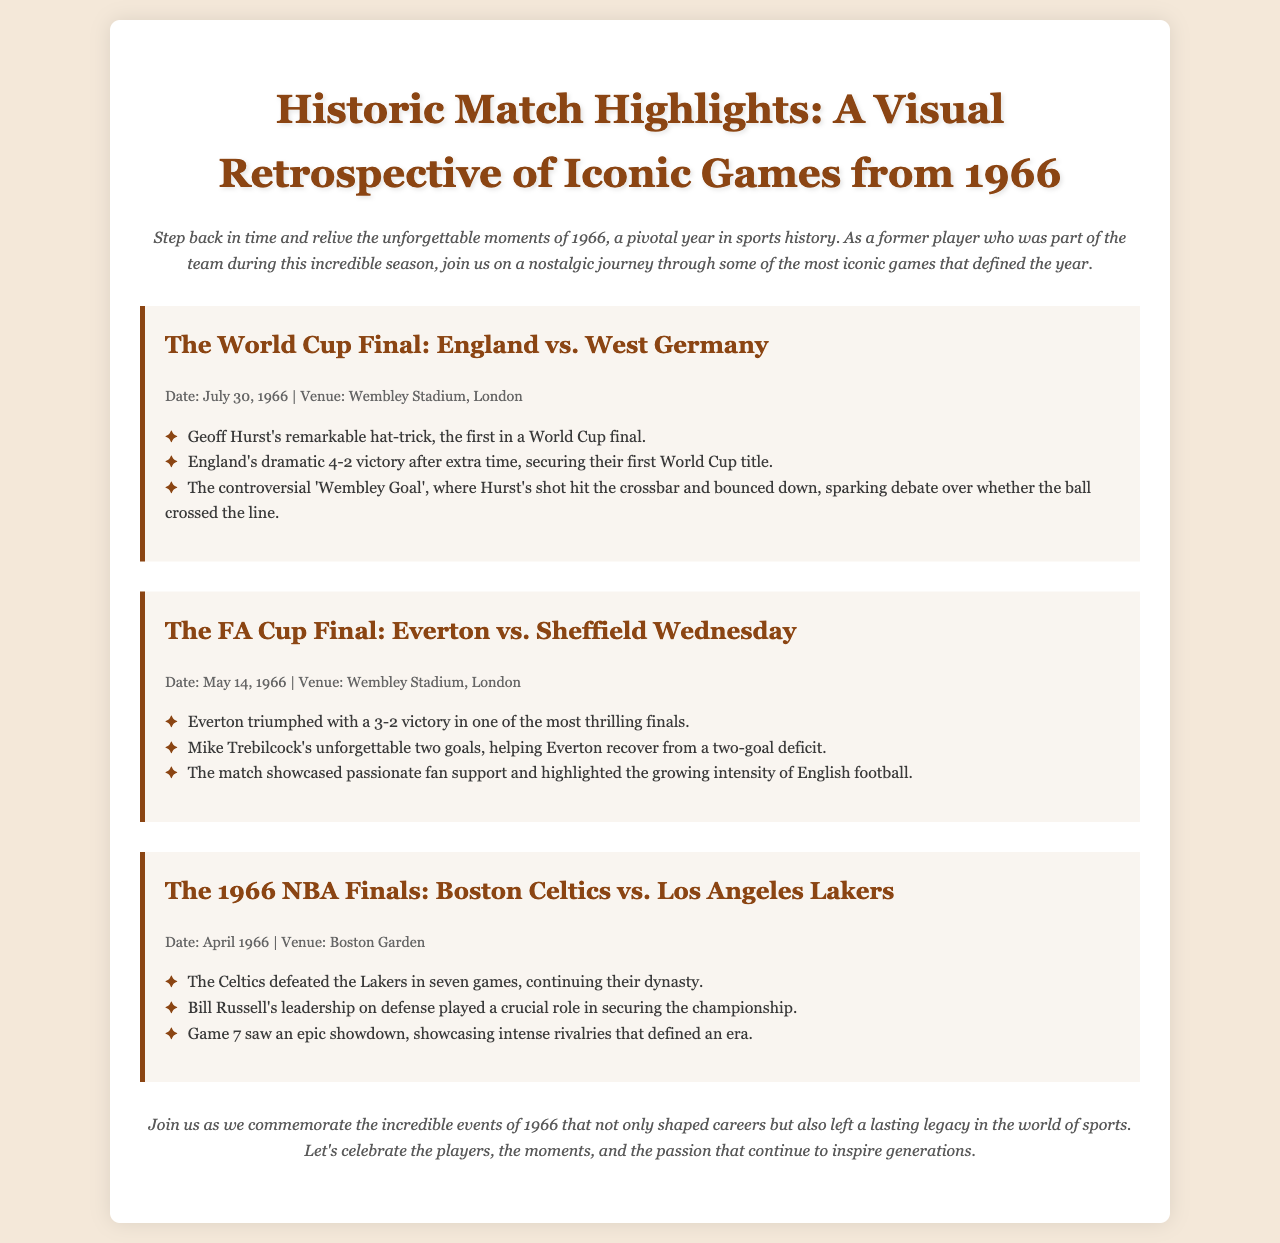What was the date of the World Cup Final? The World Cup Final between England and West Germany was held on July 30, 1966.
Answer: July 30, 1966 Who scored a hat-trick in the World Cup Final? Geoff Hurst scored a remarkable hat-trick, the first in a World Cup final.
Answer: Geoff Hurst What was the final score of the FA Cup Final? Everton won the FA Cup Final with a score of 3-2.
Answer: 3-2 Which two teams played in the 1966 NBA Finals? The 1966 NBA Finals featured the Boston Celtics and the Los Angeles Lakers.
Answer: Boston Celtics vs. Los Angeles Lakers How many games did it take for the Celtics to defeat the Lakers in the Finals? The Celtics defeated the Lakers in seven games during the 1966 NBA Finals.
Answer: Seven games What significant event occurred for England on July 30, 1966? England secured their first World Cup title after defeating West Germany.
Answer: First World Cup title What was the notable aspect of Mike Trebilcock's performance in the FA Cup Final? Mike Trebilcock scored two crucial goals for Everton, aiding their recovery.
Answer: Two goals What role did Bill Russell play in the 1966 NBA Finals? Bill Russell's leadership on defense was crucial for the Celtics in the Finals.
Answer: Leadership on defense 